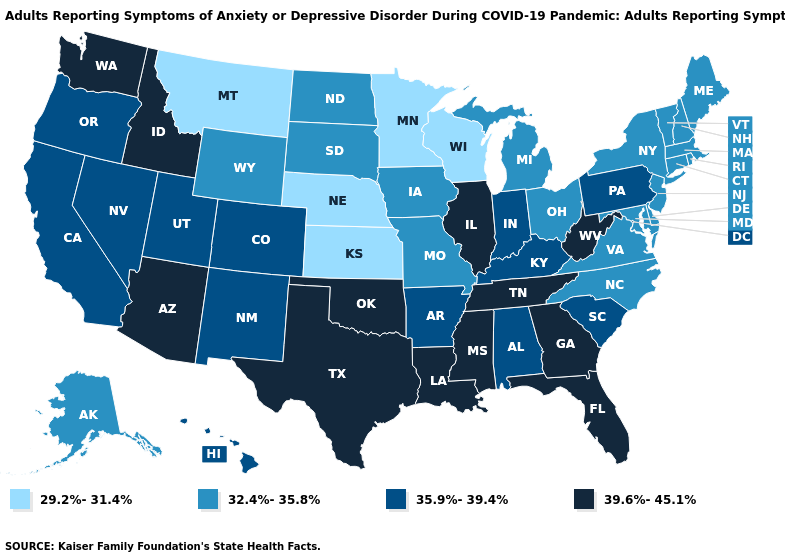What is the lowest value in the USA?
Give a very brief answer. 29.2%-31.4%. Which states have the highest value in the USA?
Answer briefly. Arizona, Florida, Georgia, Idaho, Illinois, Louisiana, Mississippi, Oklahoma, Tennessee, Texas, Washington, West Virginia. What is the highest value in the USA?
Short answer required. 39.6%-45.1%. What is the lowest value in states that border Tennessee?
Keep it brief. 32.4%-35.8%. Name the states that have a value in the range 35.9%-39.4%?
Concise answer only. Alabama, Arkansas, California, Colorado, Hawaii, Indiana, Kentucky, Nevada, New Mexico, Oregon, Pennsylvania, South Carolina, Utah. What is the value of New Hampshire?
Give a very brief answer. 32.4%-35.8%. Does Wisconsin have the lowest value in the USA?
Quick response, please. Yes. What is the lowest value in the South?
Give a very brief answer. 32.4%-35.8%. Which states hav the highest value in the South?
Quick response, please. Florida, Georgia, Louisiana, Mississippi, Oklahoma, Tennessee, Texas, West Virginia. Name the states that have a value in the range 39.6%-45.1%?
Be succinct. Arizona, Florida, Georgia, Idaho, Illinois, Louisiana, Mississippi, Oklahoma, Tennessee, Texas, Washington, West Virginia. What is the value of Georgia?
Quick response, please. 39.6%-45.1%. Name the states that have a value in the range 35.9%-39.4%?
Quick response, please. Alabama, Arkansas, California, Colorado, Hawaii, Indiana, Kentucky, Nevada, New Mexico, Oregon, Pennsylvania, South Carolina, Utah. Among the states that border West Virginia , which have the highest value?
Quick response, please. Kentucky, Pennsylvania. What is the value of Michigan?
Keep it brief. 32.4%-35.8%. Does North Dakota have the highest value in the USA?
Give a very brief answer. No. 